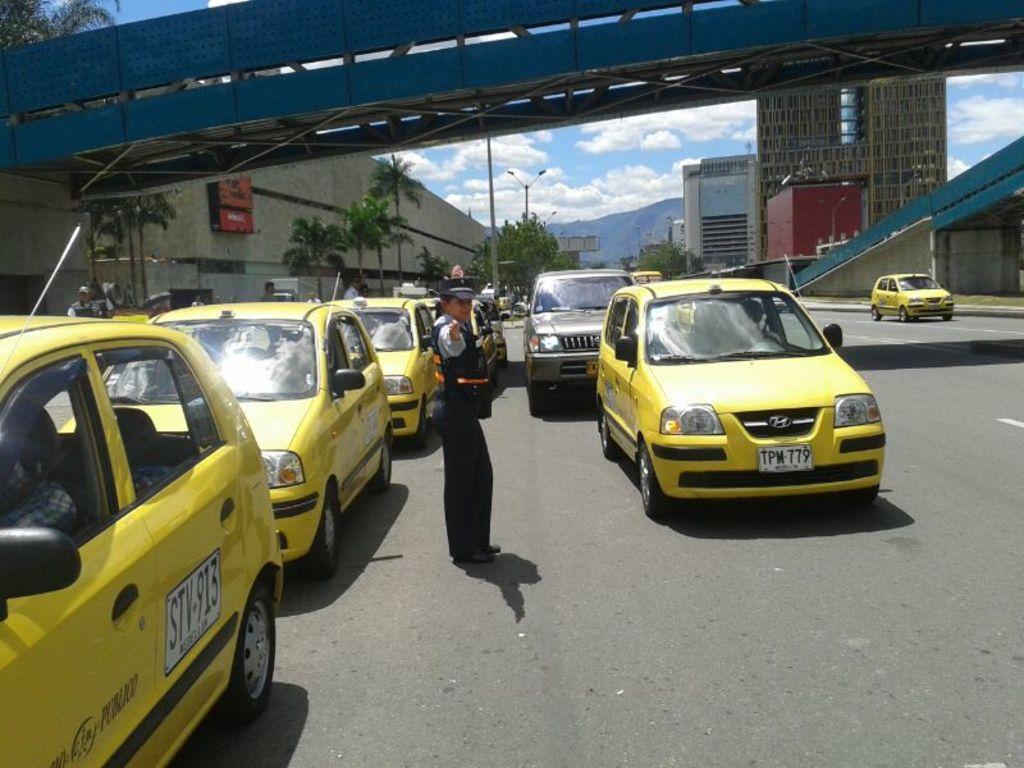What is the plate number on the left?
Offer a terse response. Stv-913. What is the front license plate number on the car to the right?
Make the answer very short. Tpm 779. 